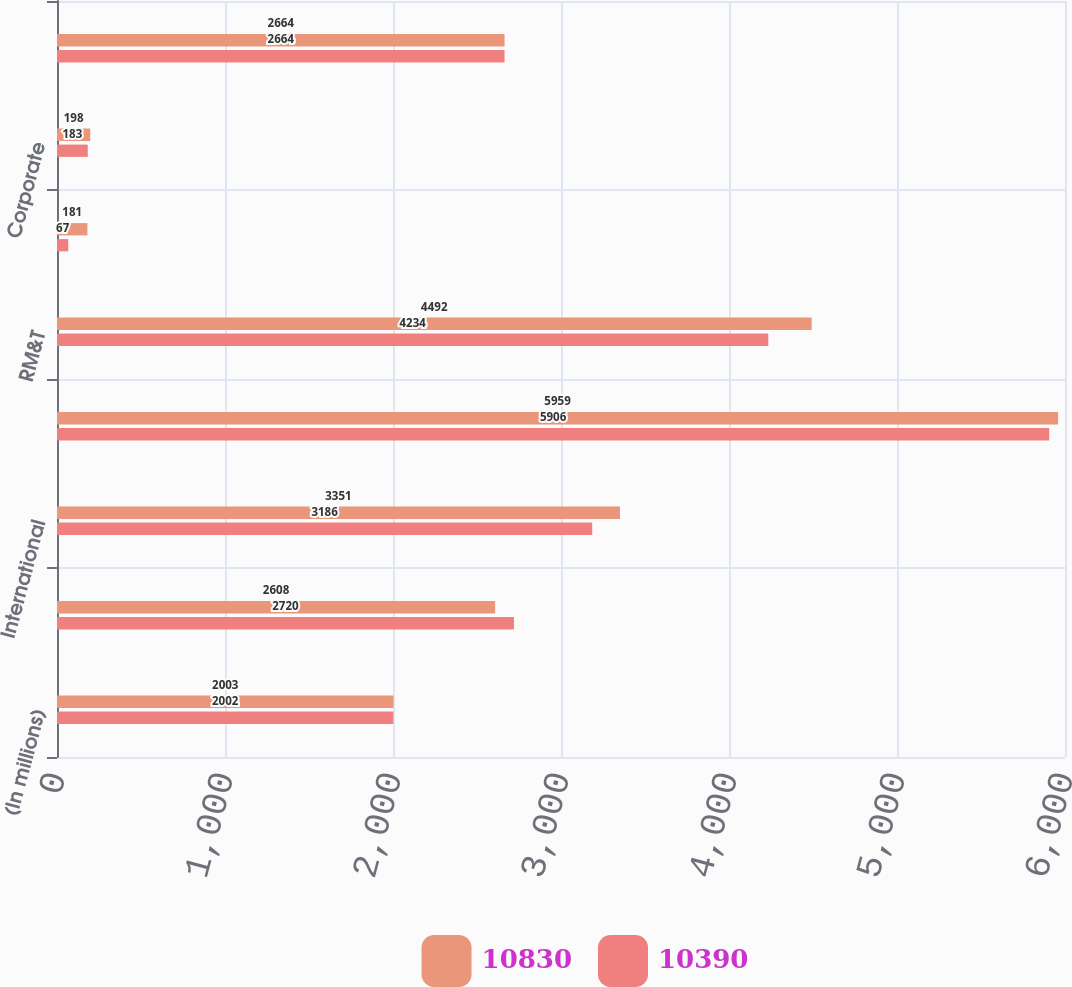Convert chart to OTSL. <chart><loc_0><loc_0><loc_500><loc_500><stacked_bar_chart><ecel><fcel>(In millions)<fcel>Domestic<fcel>International<fcel>Total E&P<fcel>RM&T<fcel>OERB<fcel>Corporate<fcel>Total<nl><fcel>10830<fcel>2003<fcel>2608<fcel>3351<fcel>5959<fcel>4492<fcel>181<fcel>198<fcel>2664<nl><fcel>10390<fcel>2002<fcel>2720<fcel>3186<fcel>5906<fcel>4234<fcel>67<fcel>183<fcel>2664<nl></chart> 